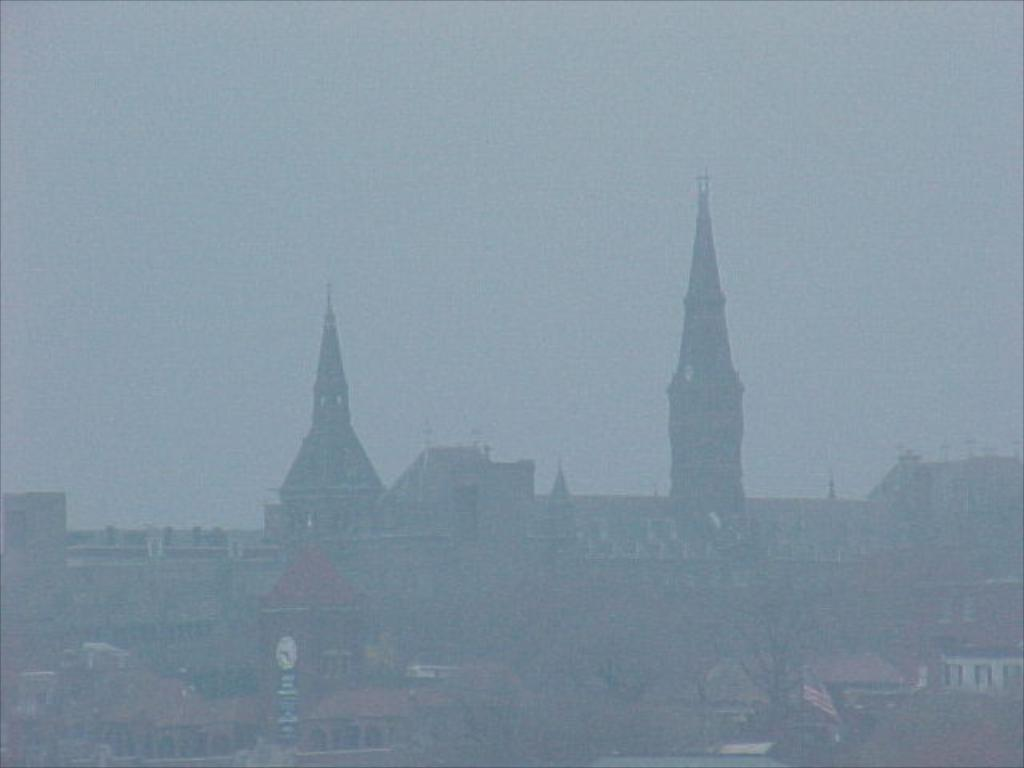What type of structures can be seen in the image? There are buildings in the image. What feature is common to many of the buildings? There are windows visible in the image. What specific building can be identified in the image? There is a clock tower in the image. What type of natural elements are present in the image? There are trees in the image. What is visible at the top of the image? The sky is visible at the top of the image. Where are the flowers arranged in the image? There are no flowers present in the image. What type of calendar is hanging on the wall in the image? There is no calendar visible in the image. 